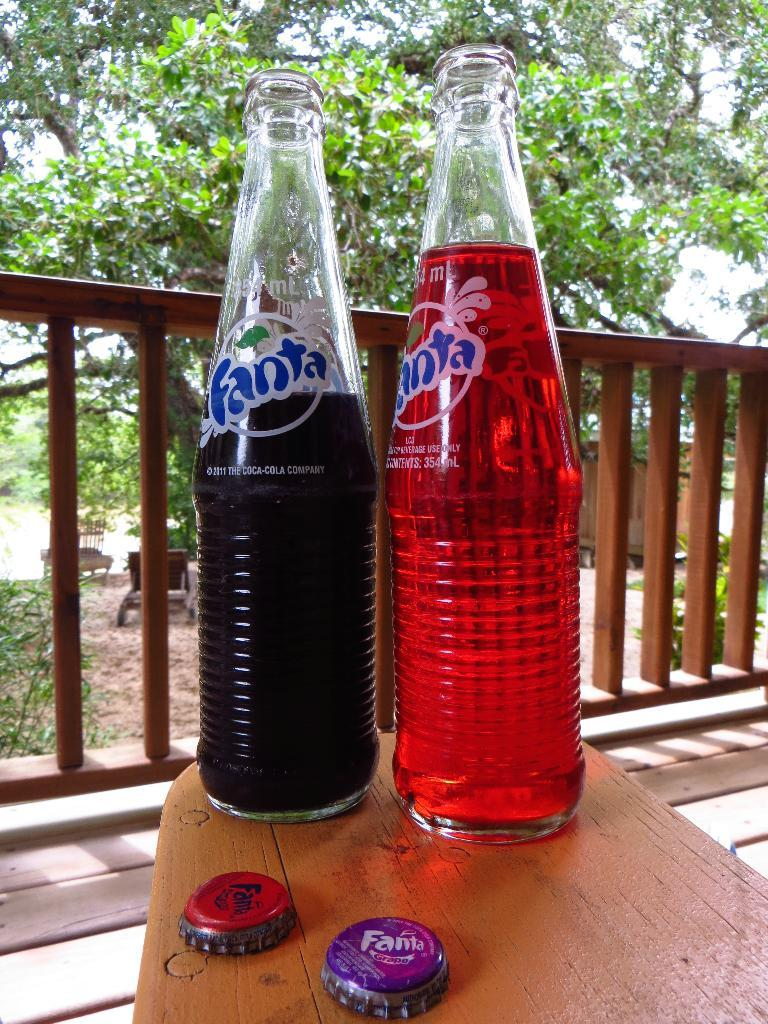<image>
Relay a brief, clear account of the picture shown. Two bottles of Fanta soda sitting on a table. 